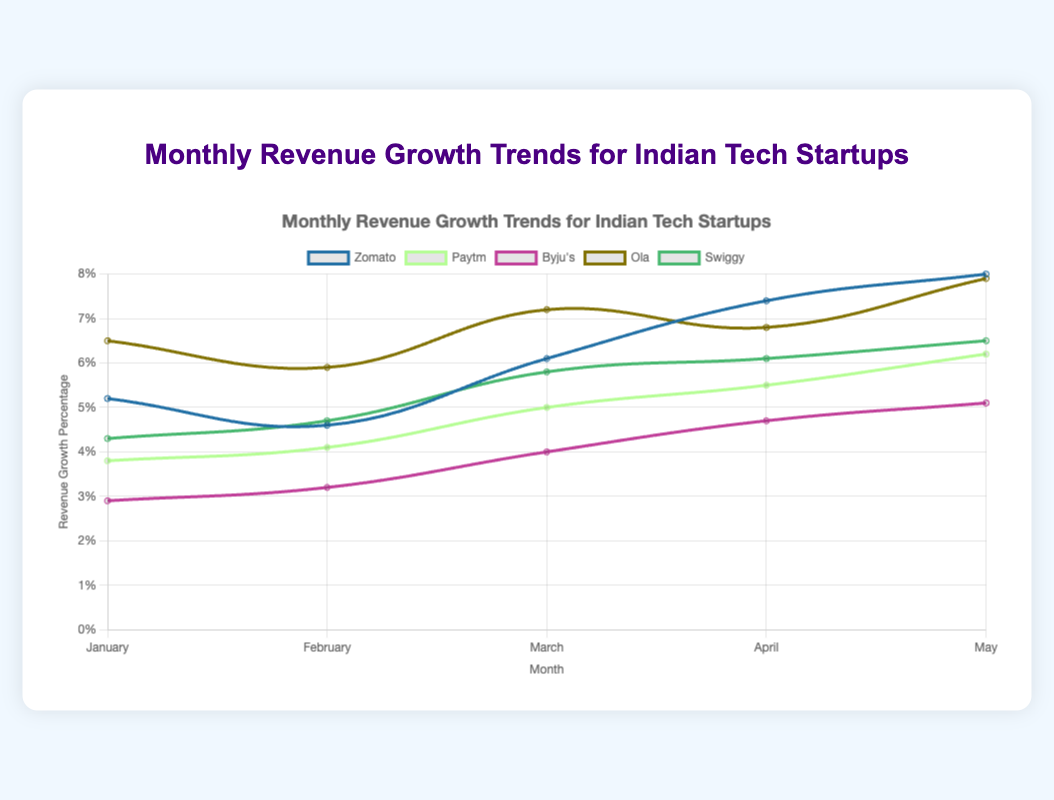Which startup had the highest revenue growth percentage in January? First, identify the data points for each startup in January. Zomato had a 5.2% growth, Paytm had 3.8%, Byju's had 2.9%, Ola had 6.5%, and Swiggy had 4.3%. The highest value here is Ola with 6.5%.
Answer: Ola Which startup showed the most consistent revenue growth over the five months? To determine consistency, we look for the startup with the least variation in growth percentages over the five months. Calculate the variance or observe fluctuations: Zomato (5.2%, 4.6%, 6.1%, 7.4%, 8.0%), Paytm (3.8%, 4.1%, 5.0%, 5.5%, 6.2%), Byju's (2.9%, 3.2%, 4.0%, 4.7%, 5.1%), Ola (6.5%, 5.9%, 7.2%, 6.8%, 7.9%), Swiggy (4.3%, 4.7%, 5.8%, 6.1%, 6.5%). Paytm shows the smallest range of growth percentages.
Answer: Paytm What was the difference in revenue growth percentage between Zomato and Byju's in March? Look at March data for both startups: Zomato had 6.1%, and Byju's had 4.0%. The difference is 6.1% - 4.0% = 2.1%.
Answer: 2.1% During which months did Paytm and Ola have the same revenue growth percentage? Check each month's data: January (3.8% vs 6.5%), February (4.1% vs 5.9%), March (5.0% vs 7.2%), April (5.5% vs 6.8%), May (6.2% vs 7.9%). There are no months where they have the same growth percentage.
Answer: None What was the average revenue growth percentage for Swiggy over the five months? Sum up Swiggy's monthly percentages and divide by the number of months: (4.3% + 4.7% + 5.8% + 6.1% + 6.5%) = 27.4%, then 27.4% / 5 = 5.48%.
Answer: 5.48% Which month had the highest overall revenue growth percentage across all startups? Sum each month's percentages across all startups: January (5.2 + 3.8 + 2.9 + 6.5 + 4.3 = 22.7), February (4.6 + 4.1 + 3.2 + 5.9 + 4.7 = 22.5), March (6.1 + 5.0 + 4.0 + 7.2 + 5.8 = 28.1), April (7.4 + 5.5 + 4.7 + 6.8 + 6.1 = 30.5), May (8.0 + 6.2 + 5.1 + 7.9 + 6.5 = 33.7). May has the highest total at 33.7%.
Answer: May How did the revenue growth percentage of Swiggy in April compare to that of Zomato in the same month? Swiggy had a 6.1% growth in April, while Zomato had a 7.4% growth. Zomato's growth is higher than Swiggy's by 1.3%.
Answer: Zomato's was higher What is the combined revenue growth percentage for Zomato and Ola in May? Sum up Zomato's and Ola's percentages for May: 8.0% (Zomato) + 7.9% (Ola) = 15.9%.
Answer: 15.9% What trend can be observed in Byju's revenue growth over the five months? By looking at Byju's monthly growth: January (2.9%), February (3.2%), March (4.0%), April (4.7%), May (5.1%), it consistently increases every month.
Answer: Consistent increase 